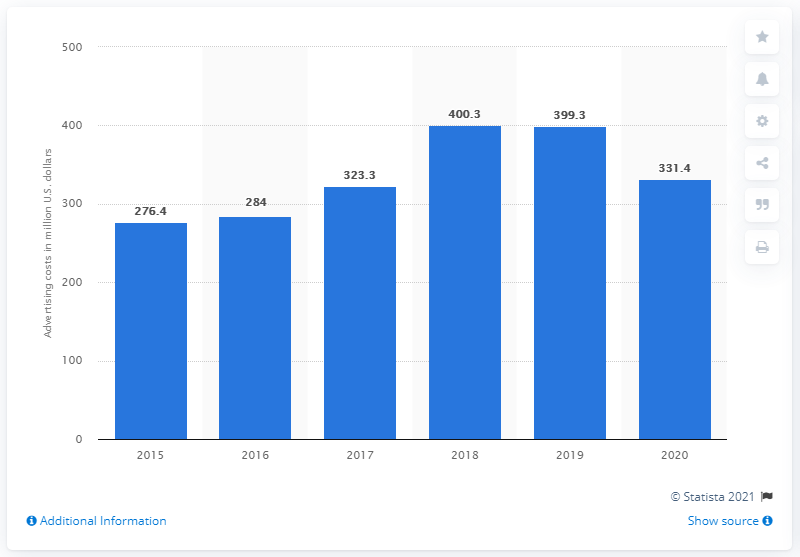Indicate a few pertinent items in this graphic. Levi Strauss spent $276.4 million on advertising and promotion in 2015. 